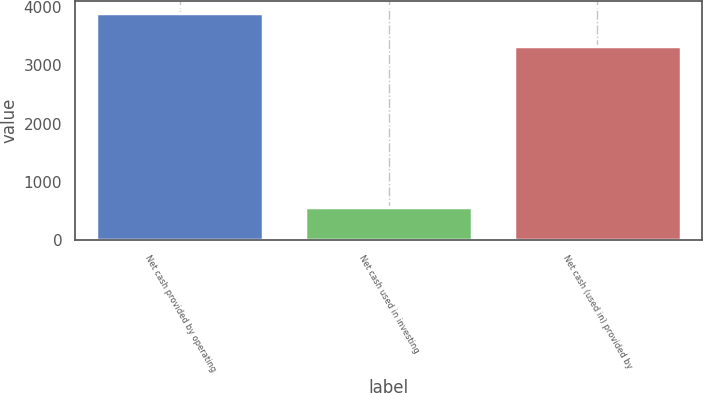Convert chart to OTSL. <chart><loc_0><loc_0><loc_500><loc_500><bar_chart><fcel>Net cash provided by operating<fcel>Net cash used in investing<fcel>Net cash (used in) provided by<nl><fcel>3899<fcel>579<fcel>3336<nl></chart> 